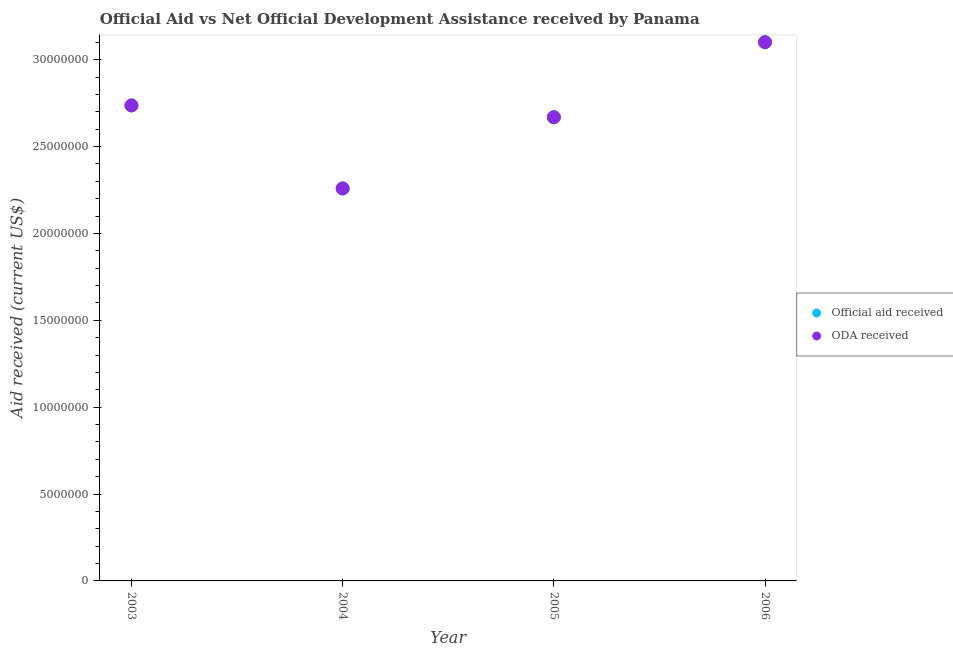How many different coloured dotlines are there?
Give a very brief answer. 2. Is the number of dotlines equal to the number of legend labels?
Make the answer very short. Yes. What is the oda received in 2005?
Make the answer very short. 2.67e+07. Across all years, what is the maximum official aid received?
Offer a very short reply. 3.10e+07. Across all years, what is the minimum official aid received?
Your answer should be compact. 2.26e+07. In which year was the oda received maximum?
Give a very brief answer. 2006. What is the total official aid received in the graph?
Your response must be concise. 1.08e+08. What is the difference between the oda received in 2004 and that in 2005?
Give a very brief answer. -4.10e+06. What is the difference between the official aid received in 2005 and the oda received in 2004?
Give a very brief answer. 4.10e+06. What is the average oda received per year?
Make the answer very short. 2.69e+07. What is the ratio of the official aid received in 2003 to that in 2004?
Your answer should be very brief. 1.21. Is the official aid received in 2003 less than that in 2004?
Provide a succinct answer. No. Is the difference between the oda received in 2003 and 2005 greater than the difference between the official aid received in 2003 and 2005?
Make the answer very short. No. What is the difference between the highest and the second highest official aid received?
Provide a succinct answer. 3.64e+06. What is the difference between the highest and the lowest oda received?
Provide a succinct answer. 8.42e+06. Is the sum of the oda received in 2003 and 2004 greater than the maximum official aid received across all years?
Your answer should be very brief. Yes. Is the official aid received strictly less than the oda received over the years?
Make the answer very short. No. What is the difference between two consecutive major ticks on the Y-axis?
Your response must be concise. 5.00e+06. Does the graph contain grids?
Your response must be concise. No. Where does the legend appear in the graph?
Make the answer very short. Center right. What is the title of the graph?
Offer a very short reply. Official Aid vs Net Official Development Assistance received by Panama . What is the label or title of the Y-axis?
Make the answer very short. Aid received (current US$). What is the Aid received (current US$) in Official aid received in 2003?
Offer a terse response. 2.74e+07. What is the Aid received (current US$) of ODA received in 2003?
Provide a short and direct response. 2.74e+07. What is the Aid received (current US$) of Official aid received in 2004?
Keep it short and to the point. 2.26e+07. What is the Aid received (current US$) in ODA received in 2004?
Keep it short and to the point. 2.26e+07. What is the Aid received (current US$) of Official aid received in 2005?
Provide a short and direct response. 2.67e+07. What is the Aid received (current US$) of ODA received in 2005?
Provide a succinct answer. 2.67e+07. What is the Aid received (current US$) of Official aid received in 2006?
Offer a terse response. 3.10e+07. What is the Aid received (current US$) in ODA received in 2006?
Offer a terse response. 3.10e+07. Across all years, what is the maximum Aid received (current US$) in Official aid received?
Keep it short and to the point. 3.10e+07. Across all years, what is the maximum Aid received (current US$) in ODA received?
Your response must be concise. 3.10e+07. Across all years, what is the minimum Aid received (current US$) of Official aid received?
Your answer should be compact. 2.26e+07. Across all years, what is the minimum Aid received (current US$) of ODA received?
Your response must be concise. 2.26e+07. What is the total Aid received (current US$) of Official aid received in the graph?
Provide a short and direct response. 1.08e+08. What is the total Aid received (current US$) in ODA received in the graph?
Give a very brief answer. 1.08e+08. What is the difference between the Aid received (current US$) of Official aid received in 2003 and that in 2004?
Make the answer very short. 4.78e+06. What is the difference between the Aid received (current US$) of ODA received in 2003 and that in 2004?
Keep it short and to the point. 4.78e+06. What is the difference between the Aid received (current US$) of Official aid received in 2003 and that in 2005?
Your answer should be very brief. 6.80e+05. What is the difference between the Aid received (current US$) in ODA received in 2003 and that in 2005?
Your response must be concise. 6.80e+05. What is the difference between the Aid received (current US$) in Official aid received in 2003 and that in 2006?
Keep it short and to the point. -3.64e+06. What is the difference between the Aid received (current US$) of ODA received in 2003 and that in 2006?
Ensure brevity in your answer.  -3.64e+06. What is the difference between the Aid received (current US$) of Official aid received in 2004 and that in 2005?
Make the answer very short. -4.10e+06. What is the difference between the Aid received (current US$) of ODA received in 2004 and that in 2005?
Give a very brief answer. -4.10e+06. What is the difference between the Aid received (current US$) of Official aid received in 2004 and that in 2006?
Provide a succinct answer. -8.42e+06. What is the difference between the Aid received (current US$) of ODA received in 2004 and that in 2006?
Offer a very short reply. -8.42e+06. What is the difference between the Aid received (current US$) in Official aid received in 2005 and that in 2006?
Your answer should be very brief. -4.32e+06. What is the difference between the Aid received (current US$) in ODA received in 2005 and that in 2006?
Your answer should be very brief. -4.32e+06. What is the difference between the Aid received (current US$) of Official aid received in 2003 and the Aid received (current US$) of ODA received in 2004?
Keep it short and to the point. 4.78e+06. What is the difference between the Aid received (current US$) of Official aid received in 2003 and the Aid received (current US$) of ODA received in 2005?
Offer a terse response. 6.80e+05. What is the difference between the Aid received (current US$) of Official aid received in 2003 and the Aid received (current US$) of ODA received in 2006?
Offer a very short reply. -3.64e+06. What is the difference between the Aid received (current US$) of Official aid received in 2004 and the Aid received (current US$) of ODA received in 2005?
Give a very brief answer. -4.10e+06. What is the difference between the Aid received (current US$) of Official aid received in 2004 and the Aid received (current US$) of ODA received in 2006?
Offer a terse response. -8.42e+06. What is the difference between the Aid received (current US$) in Official aid received in 2005 and the Aid received (current US$) in ODA received in 2006?
Offer a very short reply. -4.32e+06. What is the average Aid received (current US$) of Official aid received per year?
Provide a succinct answer. 2.69e+07. What is the average Aid received (current US$) of ODA received per year?
Ensure brevity in your answer.  2.69e+07. In the year 2006, what is the difference between the Aid received (current US$) of Official aid received and Aid received (current US$) of ODA received?
Offer a terse response. 0. What is the ratio of the Aid received (current US$) of Official aid received in 2003 to that in 2004?
Provide a short and direct response. 1.21. What is the ratio of the Aid received (current US$) of ODA received in 2003 to that in 2004?
Offer a terse response. 1.21. What is the ratio of the Aid received (current US$) in Official aid received in 2003 to that in 2005?
Provide a succinct answer. 1.03. What is the ratio of the Aid received (current US$) of ODA received in 2003 to that in 2005?
Offer a terse response. 1.03. What is the ratio of the Aid received (current US$) in Official aid received in 2003 to that in 2006?
Ensure brevity in your answer.  0.88. What is the ratio of the Aid received (current US$) in ODA received in 2003 to that in 2006?
Your answer should be very brief. 0.88. What is the ratio of the Aid received (current US$) of Official aid received in 2004 to that in 2005?
Offer a terse response. 0.85. What is the ratio of the Aid received (current US$) of ODA received in 2004 to that in 2005?
Your answer should be compact. 0.85. What is the ratio of the Aid received (current US$) in Official aid received in 2004 to that in 2006?
Keep it short and to the point. 0.73. What is the ratio of the Aid received (current US$) of ODA received in 2004 to that in 2006?
Provide a succinct answer. 0.73. What is the ratio of the Aid received (current US$) of Official aid received in 2005 to that in 2006?
Your answer should be very brief. 0.86. What is the ratio of the Aid received (current US$) in ODA received in 2005 to that in 2006?
Your answer should be compact. 0.86. What is the difference between the highest and the second highest Aid received (current US$) of Official aid received?
Offer a very short reply. 3.64e+06. What is the difference between the highest and the second highest Aid received (current US$) of ODA received?
Make the answer very short. 3.64e+06. What is the difference between the highest and the lowest Aid received (current US$) of Official aid received?
Keep it short and to the point. 8.42e+06. What is the difference between the highest and the lowest Aid received (current US$) in ODA received?
Your response must be concise. 8.42e+06. 